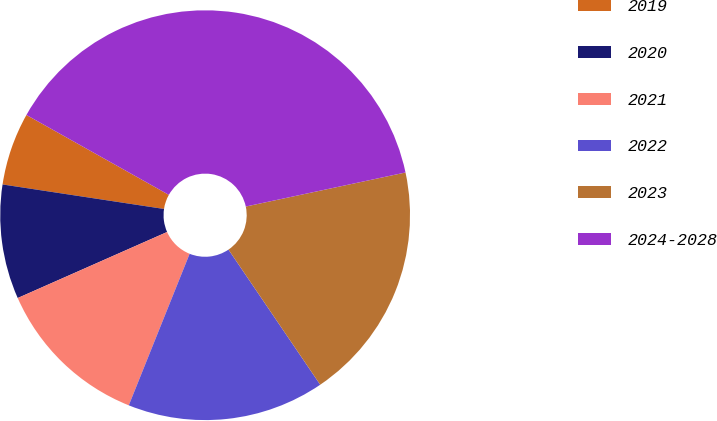Convert chart. <chart><loc_0><loc_0><loc_500><loc_500><pie_chart><fcel>2019<fcel>2020<fcel>2021<fcel>2022<fcel>2023<fcel>2024-2028<nl><fcel>5.74%<fcel>9.02%<fcel>12.3%<fcel>15.57%<fcel>18.85%<fcel>38.52%<nl></chart> 